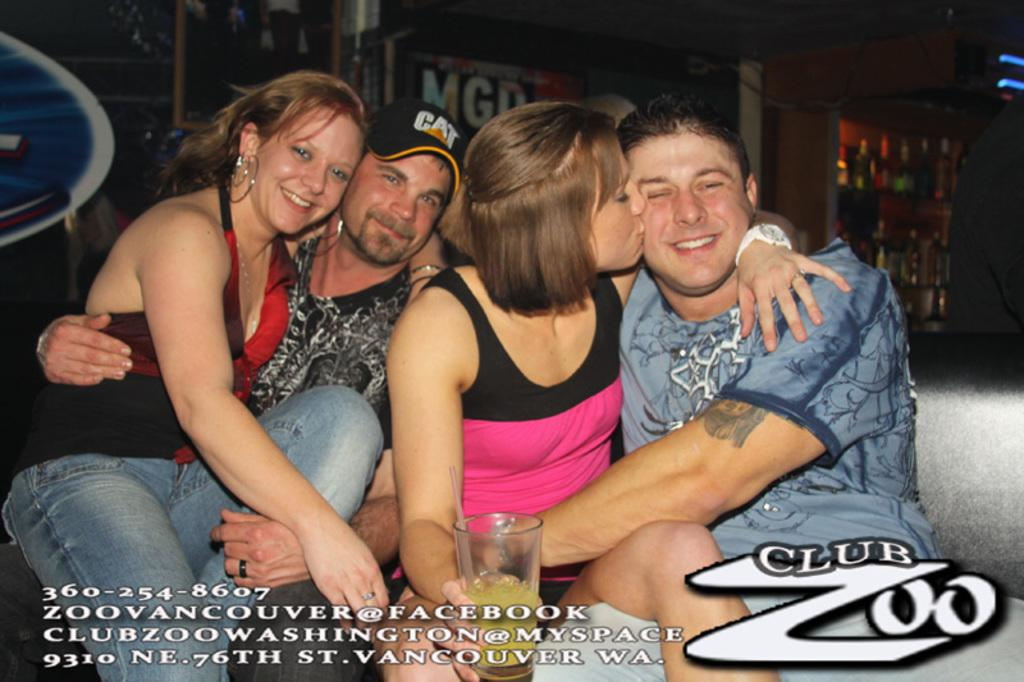How many persons are in the foreground of the image? There are four persons in the foreground of the image. What objects are also present in the foreground of the image? There is a glass, text, and a logo in the foreground of the image. What can be seen in the background of the image? Ships, lights, and liquor bottles on a shelf can be seen in the background of the image. Can you describe the lighting conditions in the image? The image may have been taken during the night, as there are lights visible in the background. How many trees can be seen in the image? There are no trees visible in the image. What emotion might the persons in the image be feeling, based on the presence of regret? There is no indication of regret or any specific emotions in the image, as it only shows four persons, a glass, text, a logo, ships, lights, and liquor bottles on a shelf. 